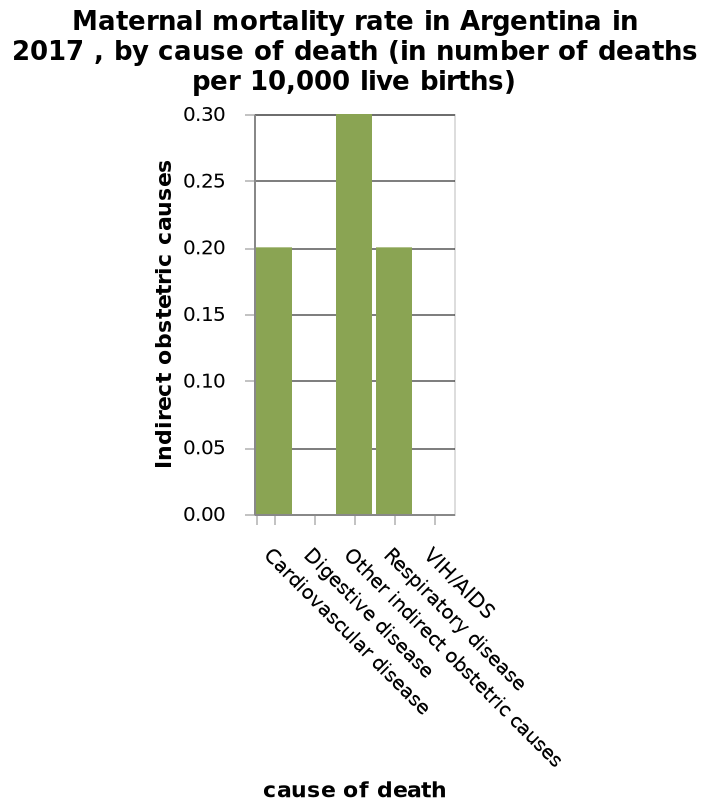<image>
What does the bar chart for maternal mortality rate in Argentina in 2017 reveal about digestive disease?  The bar chart reveals that digestive disease is the leading cause of death on the chart. Describe the following image in detail This bar chart is labeled Maternal mortality rate in Argentina in 2017 , by cause of death (in number of deaths per 10,000 live births). Along the x-axis, cause of death is defined with a categorical scale with Cardiovascular disease on one end and  at the other. Indirect obstetric causes is drawn using a scale with a minimum of 0.00 and a maximum of 0.30 on the y-axis. What is the lowest cause of death on the bar chart for maternal mortality rate in Argentina in 2017?  The lowest cause of death on the bar chart is digestive disease. Is the highest cause of death on the bar chart digestive disease? No. The lowest cause of death on the bar chart is digestive disease. 